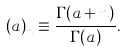<formula> <loc_0><loc_0><loc_500><loc_500>\left ( a \right ) _ { n } \equiv \frac { \Gamma ( a + n ) } { \Gamma ( a ) } .</formula> 